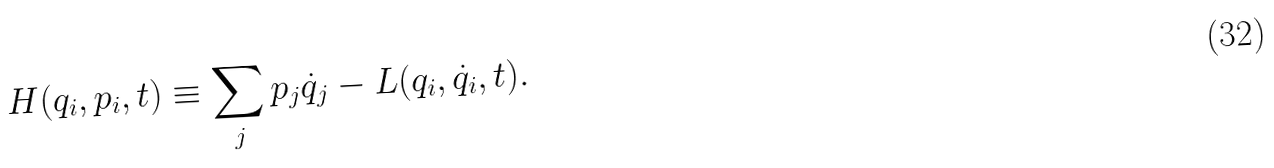Convert formula to latex. <formula><loc_0><loc_0><loc_500><loc_500>H ( q _ { i } , p _ { i } , t ) \equiv \sum _ { j } p _ { j } \dot { q } _ { j } - L ( q _ { i } , \dot { q } _ { i } , t ) .</formula> 